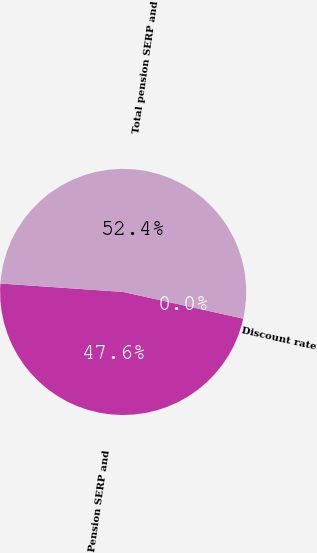<chart> <loc_0><loc_0><loc_500><loc_500><pie_chart><fcel>Discount rate<fcel>Pension SERP and<fcel>Total pension SERP and<nl><fcel>0.0%<fcel>47.61%<fcel>52.39%<nl></chart> 